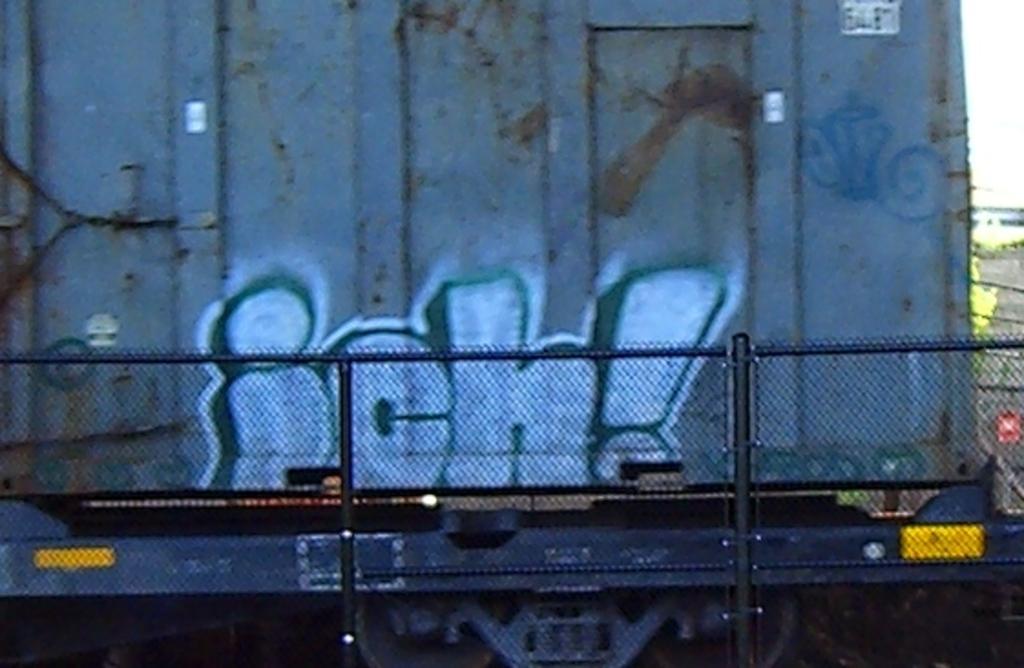What punctuation is used on this grafitti?
Offer a very short reply. !. 